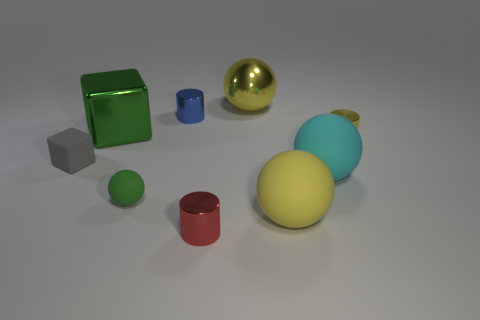The red object has what shape?
Your answer should be very brief. Cylinder. How many cyan things are either large balls or shiny blocks?
Keep it short and to the point. 1. How many other things are made of the same material as the small yellow cylinder?
Provide a short and direct response. 4. Is the shape of the metal object to the left of the blue metallic cylinder the same as  the small green rubber object?
Your response must be concise. No. Are any small red rubber blocks visible?
Provide a short and direct response. No. Is there any other thing that has the same shape as the green matte thing?
Keep it short and to the point. Yes. Are there more red metallic cylinders to the right of the tiny red metal object than blue things?
Ensure brevity in your answer.  No. There is a large green thing; are there any big blocks to the right of it?
Your answer should be compact. No. Is the red cylinder the same size as the green sphere?
Make the answer very short. Yes. There is a green shiny object that is the same shape as the tiny gray rubber object; what size is it?
Make the answer very short. Large. 